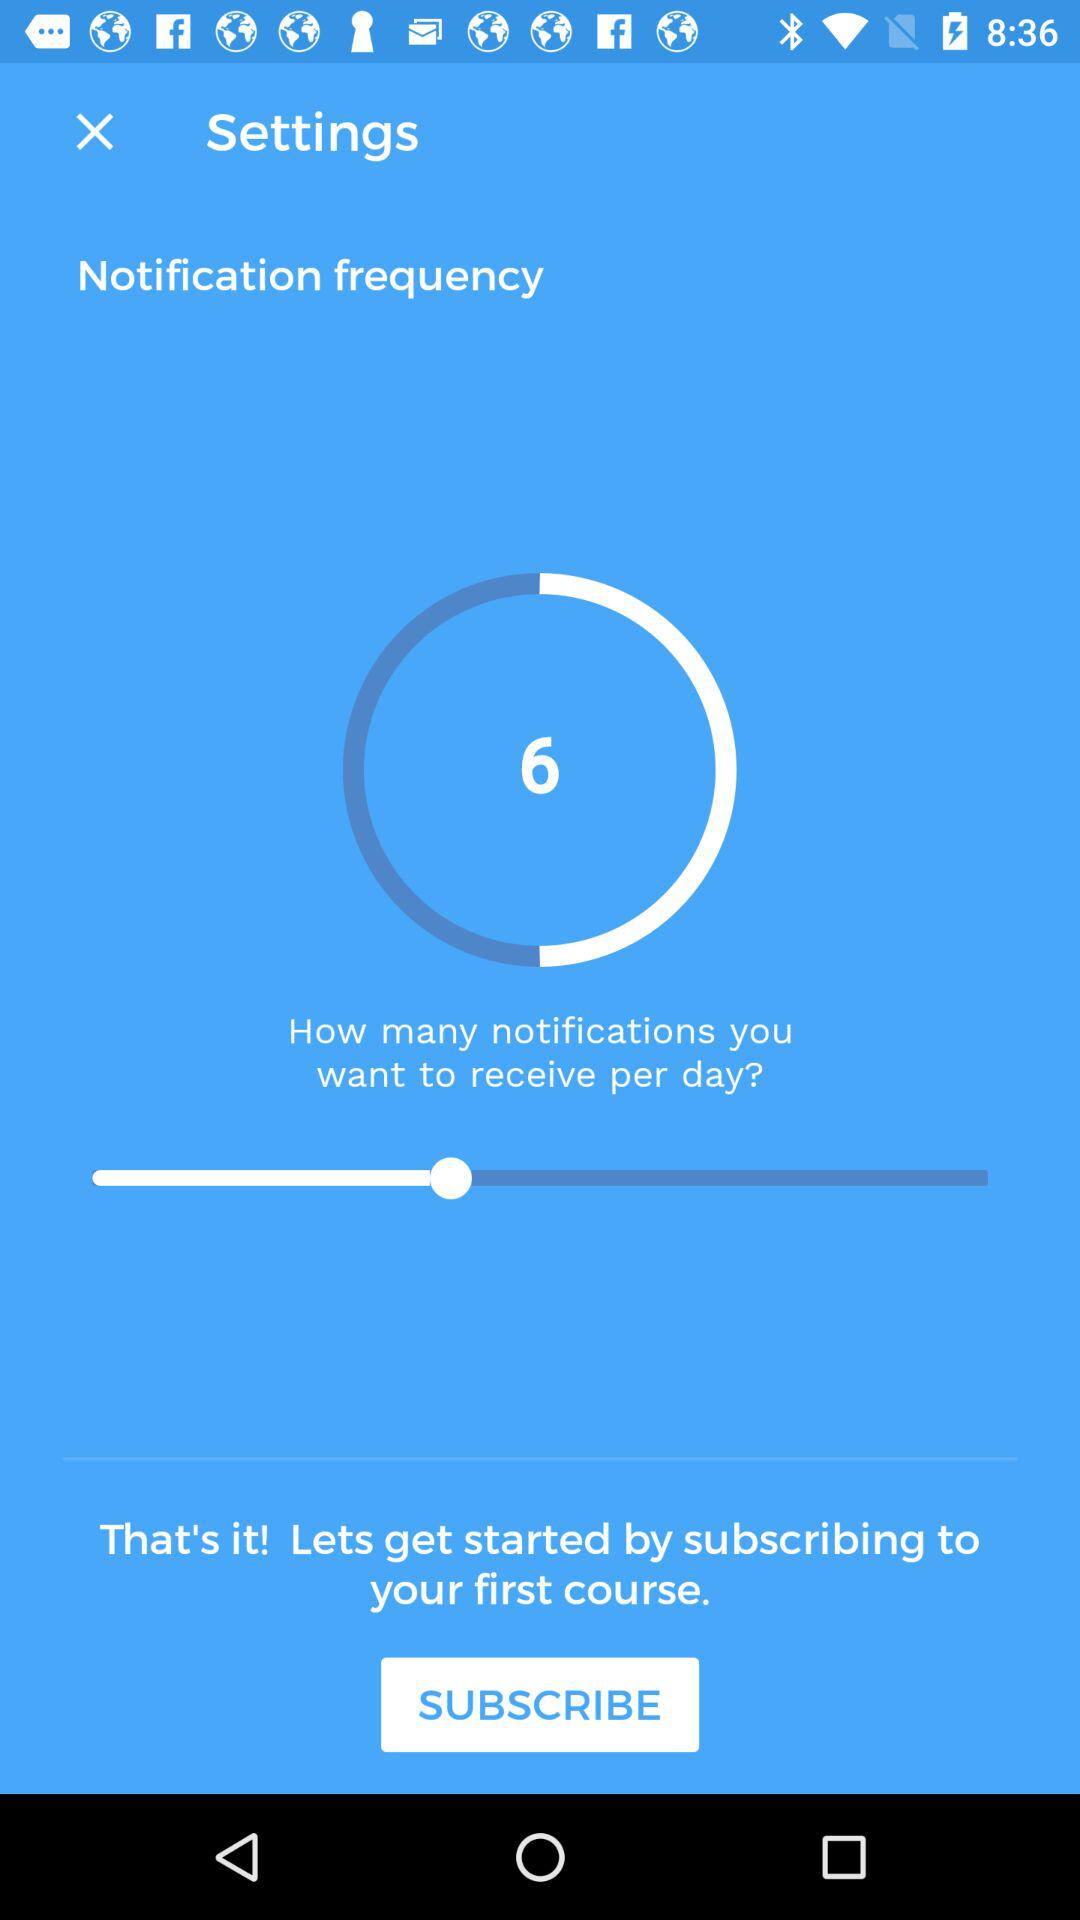How many notifications do you want to receive per day? The number of notifications is 6. 